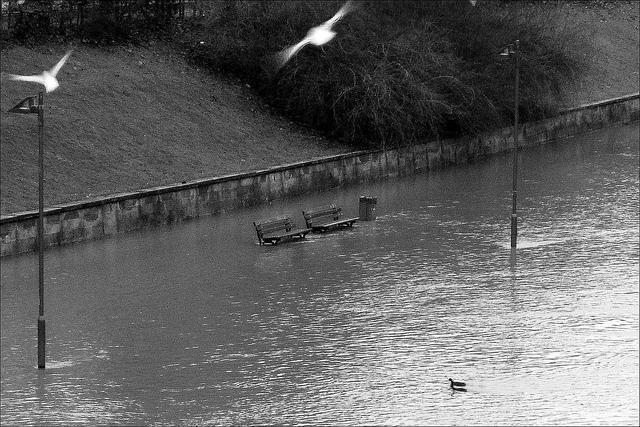How many park benches have been flooded?
Give a very brief answer. 2. 